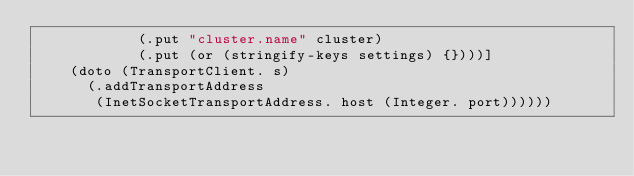<code> <loc_0><loc_0><loc_500><loc_500><_Clojure_>            (.put "cluster.name" cluster)
            (.put (or (stringify-keys settings) {})))]
    (doto (TransportClient. s)
      (.addTransportAddress
       (InetSocketTransportAddress. host (Integer. port))))))

</code> 